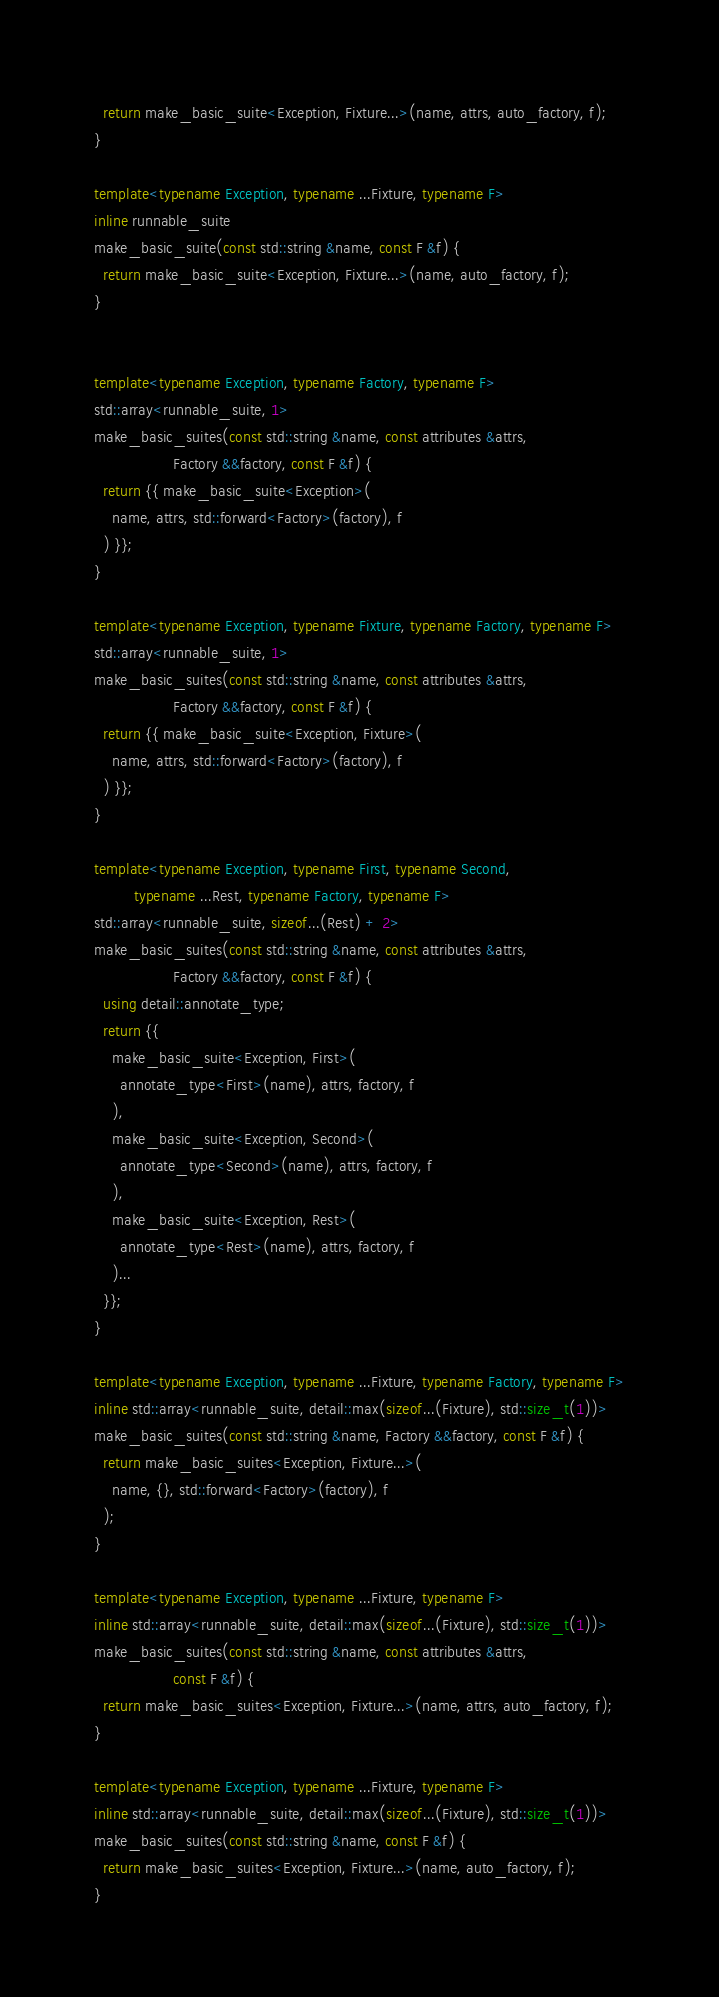<code> <loc_0><loc_0><loc_500><loc_500><_C++_>  return make_basic_suite<Exception, Fixture...>(name, attrs, auto_factory, f);
}

template<typename Exception, typename ...Fixture, typename F>
inline runnable_suite
make_basic_suite(const std::string &name, const F &f) {
  return make_basic_suite<Exception, Fixture...>(name, auto_factory, f);
}


template<typename Exception, typename Factory, typename F>
std::array<runnable_suite, 1>
make_basic_suites(const std::string &name, const attributes &attrs,
                  Factory &&factory, const F &f) {
  return {{ make_basic_suite<Exception>(
    name, attrs, std::forward<Factory>(factory), f
  ) }};
}

template<typename Exception, typename Fixture, typename Factory, typename F>
std::array<runnable_suite, 1>
make_basic_suites(const std::string &name, const attributes &attrs,
                  Factory &&factory, const F &f) {
  return {{ make_basic_suite<Exception, Fixture>(
    name, attrs, std::forward<Factory>(factory), f
  ) }};
}

template<typename Exception, typename First, typename Second,
         typename ...Rest, typename Factory, typename F>
std::array<runnable_suite, sizeof...(Rest) + 2>
make_basic_suites(const std::string &name, const attributes &attrs,
                  Factory &&factory, const F &f) {
  using detail::annotate_type;
  return {{
    make_basic_suite<Exception, First>(
      annotate_type<First>(name), attrs, factory, f
    ),
    make_basic_suite<Exception, Second>(
      annotate_type<Second>(name), attrs, factory, f
    ),
    make_basic_suite<Exception, Rest>(
      annotate_type<Rest>(name), attrs, factory, f
    )...
  }};
}

template<typename Exception, typename ...Fixture, typename Factory, typename F>
inline std::array<runnable_suite, detail::max(sizeof...(Fixture), std::size_t(1))>
make_basic_suites(const std::string &name, Factory &&factory, const F &f) {
  return make_basic_suites<Exception, Fixture...>(
    name, {}, std::forward<Factory>(factory), f
  );
}

template<typename Exception, typename ...Fixture, typename F>
inline std::array<runnable_suite, detail::max(sizeof...(Fixture), std::size_t(1))>
make_basic_suites(const std::string &name, const attributes &attrs,
                  const F &f) {
  return make_basic_suites<Exception, Fixture...>(name, attrs, auto_factory, f);
}

template<typename Exception, typename ...Fixture, typename F>
inline std::array<runnable_suite, detail::max(sizeof...(Fixture), std::size_t(1))>
make_basic_suites(const std::string &name, const F &f) {
  return make_basic_suites<Exception, Fixture...>(name, auto_factory, f);
}

</code> 